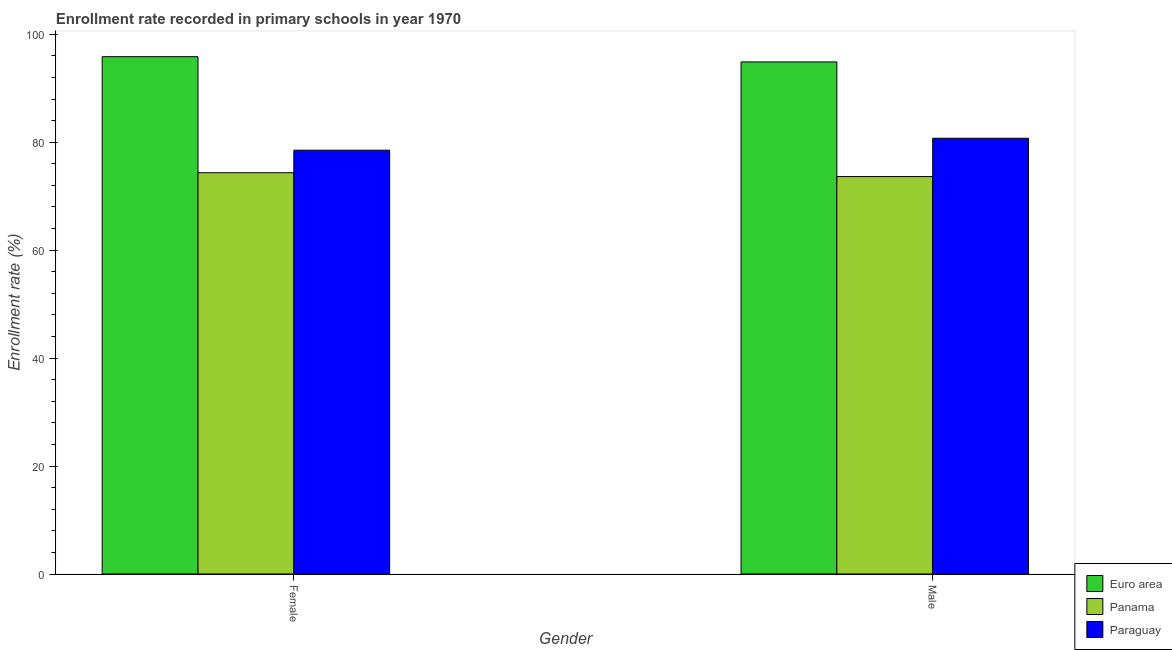How many different coloured bars are there?
Offer a very short reply. 3. How many bars are there on the 1st tick from the left?
Provide a short and direct response. 3. What is the label of the 2nd group of bars from the left?
Keep it short and to the point. Male. What is the enrollment rate of male students in Euro area?
Your response must be concise. 94.87. Across all countries, what is the maximum enrollment rate of male students?
Offer a very short reply. 94.87. Across all countries, what is the minimum enrollment rate of female students?
Your answer should be very brief. 74.34. In which country was the enrollment rate of female students maximum?
Your answer should be very brief. Euro area. In which country was the enrollment rate of female students minimum?
Ensure brevity in your answer.  Panama. What is the total enrollment rate of male students in the graph?
Ensure brevity in your answer.  249.23. What is the difference between the enrollment rate of male students in Paraguay and that in Euro area?
Provide a short and direct response. -14.14. What is the difference between the enrollment rate of female students in Paraguay and the enrollment rate of male students in Euro area?
Ensure brevity in your answer.  -16.35. What is the average enrollment rate of female students per country?
Your response must be concise. 82.9. What is the difference between the enrollment rate of female students and enrollment rate of male students in Paraguay?
Your answer should be very brief. -2.21. What is the ratio of the enrollment rate of female students in Panama to that in Paraguay?
Keep it short and to the point. 0.95. In how many countries, is the enrollment rate of male students greater than the average enrollment rate of male students taken over all countries?
Provide a short and direct response. 1. What does the 3rd bar from the left in Male represents?
Provide a succinct answer. Paraguay. What does the 3rd bar from the right in Female represents?
Offer a very short reply. Euro area. How many bars are there?
Your response must be concise. 6. How many countries are there in the graph?
Your answer should be compact. 3. Does the graph contain any zero values?
Provide a succinct answer. No. Where does the legend appear in the graph?
Your answer should be compact. Bottom right. How many legend labels are there?
Your response must be concise. 3. How are the legend labels stacked?
Offer a very short reply. Vertical. What is the title of the graph?
Your answer should be compact. Enrollment rate recorded in primary schools in year 1970. What is the label or title of the X-axis?
Ensure brevity in your answer.  Gender. What is the label or title of the Y-axis?
Your response must be concise. Enrollment rate (%). What is the Enrollment rate (%) of Euro area in Female?
Make the answer very short. 95.84. What is the Enrollment rate (%) of Panama in Female?
Your answer should be compact. 74.34. What is the Enrollment rate (%) in Paraguay in Female?
Provide a short and direct response. 78.52. What is the Enrollment rate (%) of Euro area in Male?
Give a very brief answer. 94.87. What is the Enrollment rate (%) in Panama in Male?
Ensure brevity in your answer.  73.63. What is the Enrollment rate (%) of Paraguay in Male?
Provide a short and direct response. 80.73. Across all Gender, what is the maximum Enrollment rate (%) of Euro area?
Keep it short and to the point. 95.84. Across all Gender, what is the maximum Enrollment rate (%) in Panama?
Keep it short and to the point. 74.34. Across all Gender, what is the maximum Enrollment rate (%) of Paraguay?
Your answer should be very brief. 80.73. Across all Gender, what is the minimum Enrollment rate (%) of Euro area?
Give a very brief answer. 94.87. Across all Gender, what is the minimum Enrollment rate (%) in Panama?
Keep it short and to the point. 73.63. Across all Gender, what is the minimum Enrollment rate (%) of Paraguay?
Your response must be concise. 78.52. What is the total Enrollment rate (%) of Euro area in the graph?
Provide a short and direct response. 190.71. What is the total Enrollment rate (%) in Panama in the graph?
Give a very brief answer. 147.97. What is the total Enrollment rate (%) of Paraguay in the graph?
Your response must be concise. 159.25. What is the difference between the Enrollment rate (%) of Euro area in Female and that in Male?
Your response must be concise. 0.97. What is the difference between the Enrollment rate (%) in Panama in Female and that in Male?
Provide a succinct answer. 0.71. What is the difference between the Enrollment rate (%) in Paraguay in Female and that in Male?
Keep it short and to the point. -2.21. What is the difference between the Enrollment rate (%) in Euro area in Female and the Enrollment rate (%) in Panama in Male?
Make the answer very short. 22.21. What is the difference between the Enrollment rate (%) in Euro area in Female and the Enrollment rate (%) in Paraguay in Male?
Your response must be concise. 15.11. What is the difference between the Enrollment rate (%) of Panama in Female and the Enrollment rate (%) of Paraguay in Male?
Your answer should be very brief. -6.39. What is the average Enrollment rate (%) in Euro area per Gender?
Your response must be concise. 95.35. What is the average Enrollment rate (%) of Panama per Gender?
Offer a terse response. 73.99. What is the average Enrollment rate (%) of Paraguay per Gender?
Provide a succinct answer. 79.62. What is the difference between the Enrollment rate (%) in Euro area and Enrollment rate (%) in Panama in Female?
Your answer should be compact. 21.5. What is the difference between the Enrollment rate (%) in Euro area and Enrollment rate (%) in Paraguay in Female?
Offer a terse response. 17.32. What is the difference between the Enrollment rate (%) in Panama and Enrollment rate (%) in Paraguay in Female?
Keep it short and to the point. -4.18. What is the difference between the Enrollment rate (%) of Euro area and Enrollment rate (%) of Panama in Male?
Offer a terse response. 21.24. What is the difference between the Enrollment rate (%) of Euro area and Enrollment rate (%) of Paraguay in Male?
Your response must be concise. 14.14. What is the difference between the Enrollment rate (%) of Panama and Enrollment rate (%) of Paraguay in Male?
Provide a short and direct response. -7.1. What is the ratio of the Enrollment rate (%) of Euro area in Female to that in Male?
Provide a short and direct response. 1.01. What is the ratio of the Enrollment rate (%) in Panama in Female to that in Male?
Provide a short and direct response. 1.01. What is the ratio of the Enrollment rate (%) of Paraguay in Female to that in Male?
Make the answer very short. 0.97. What is the difference between the highest and the second highest Enrollment rate (%) of Euro area?
Ensure brevity in your answer.  0.97. What is the difference between the highest and the second highest Enrollment rate (%) of Panama?
Offer a terse response. 0.71. What is the difference between the highest and the second highest Enrollment rate (%) of Paraguay?
Give a very brief answer. 2.21. What is the difference between the highest and the lowest Enrollment rate (%) in Euro area?
Your answer should be very brief. 0.97. What is the difference between the highest and the lowest Enrollment rate (%) of Panama?
Your response must be concise. 0.71. What is the difference between the highest and the lowest Enrollment rate (%) of Paraguay?
Offer a very short reply. 2.21. 